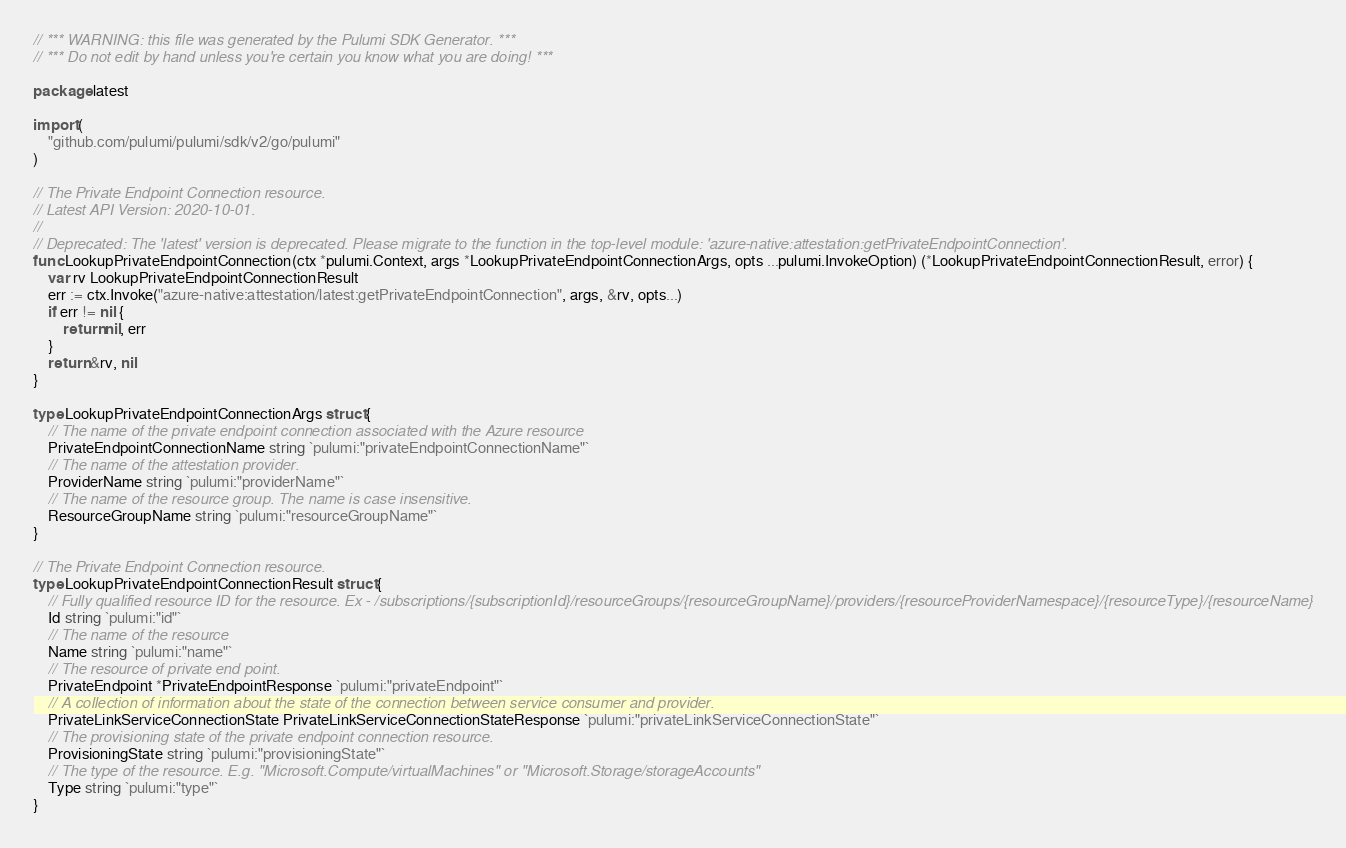Convert code to text. <code><loc_0><loc_0><loc_500><loc_500><_Go_>// *** WARNING: this file was generated by the Pulumi SDK Generator. ***
// *** Do not edit by hand unless you're certain you know what you are doing! ***

package latest

import (
	"github.com/pulumi/pulumi/sdk/v2/go/pulumi"
)

// The Private Endpoint Connection resource.
// Latest API Version: 2020-10-01.
//
// Deprecated: The 'latest' version is deprecated. Please migrate to the function in the top-level module: 'azure-native:attestation:getPrivateEndpointConnection'.
func LookupPrivateEndpointConnection(ctx *pulumi.Context, args *LookupPrivateEndpointConnectionArgs, opts ...pulumi.InvokeOption) (*LookupPrivateEndpointConnectionResult, error) {
	var rv LookupPrivateEndpointConnectionResult
	err := ctx.Invoke("azure-native:attestation/latest:getPrivateEndpointConnection", args, &rv, opts...)
	if err != nil {
		return nil, err
	}
	return &rv, nil
}

type LookupPrivateEndpointConnectionArgs struct {
	// The name of the private endpoint connection associated with the Azure resource
	PrivateEndpointConnectionName string `pulumi:"privateEndpointConnectionName"`
	// The name of the attestation provider.
	ProviderName string `pulumi:"providerName"`
	// The name of the resource group. The name is case insensitive.
	ResourceGroupName string `pulumi:"resourceGroupName"`
}

// The Private Endpoint Connection resource.
type LookupPrivateEndpointConnectionResult struct {
	// Fully qualified resource ID for the resource. Ex - /subscriptions/{subscriptionId}/resourceGroups/{resourceGroupName}/providers/{resourceProviderNamespace}/{resourceType}/{resourceName}
	Id string `pulumi:"id"`
	// The name of the resource
	Name string `pulumi:"name"`
	// The resource of private end point.
	PrivateEndpoint *PrivateEndpointResponse `pulumi:"privateEndpoint"`
	// A collection of information about the state of the connection between service consumer and provider.
	PrivateLinkServiceConnectionState PrivateLinkServiceConnectionStateResponse `pulumi:"privateLinkServiceConnectionState"`
	// The provisioning state of the private endpoint connection resource.
	ProvisioningState string `pulumi:"provisioningState"`
	// The type of the resource. E.g. "Microsoft.Compute/virtualMachines" or "Microsoft.Storage/storageAccounts"
	Type string `pulumi:"type"`
}
</code> 